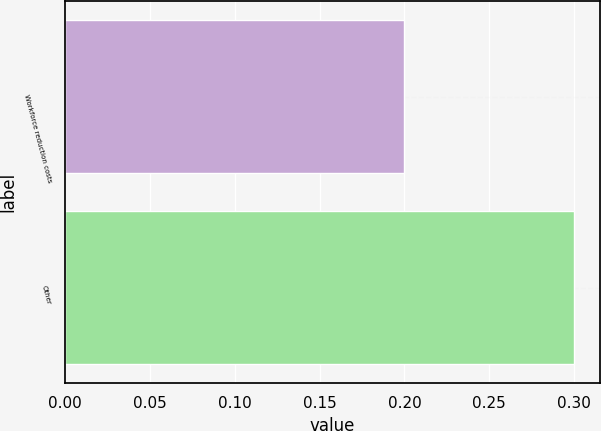<chart> <loc_0><loc_0><loc_500><loc_500><bar_chart><fcel>Workforce reduction costs<fcel>Other<nl><fcel>0.2<fcel>0.3<nl></chart> 